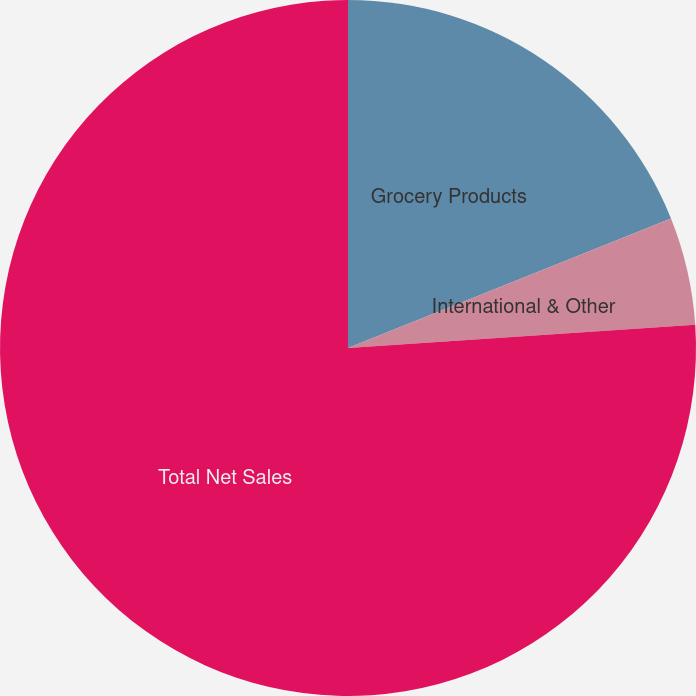<chart> <loc_0><loc_0><loc_500><loc_500><pie_chart><fcel>Grocery Products<fcel>International & Other<fcel>Total Net Sales<nl><fcel>18.93%<fcel>5.01%<fcel>76.06%<nl></chart> 